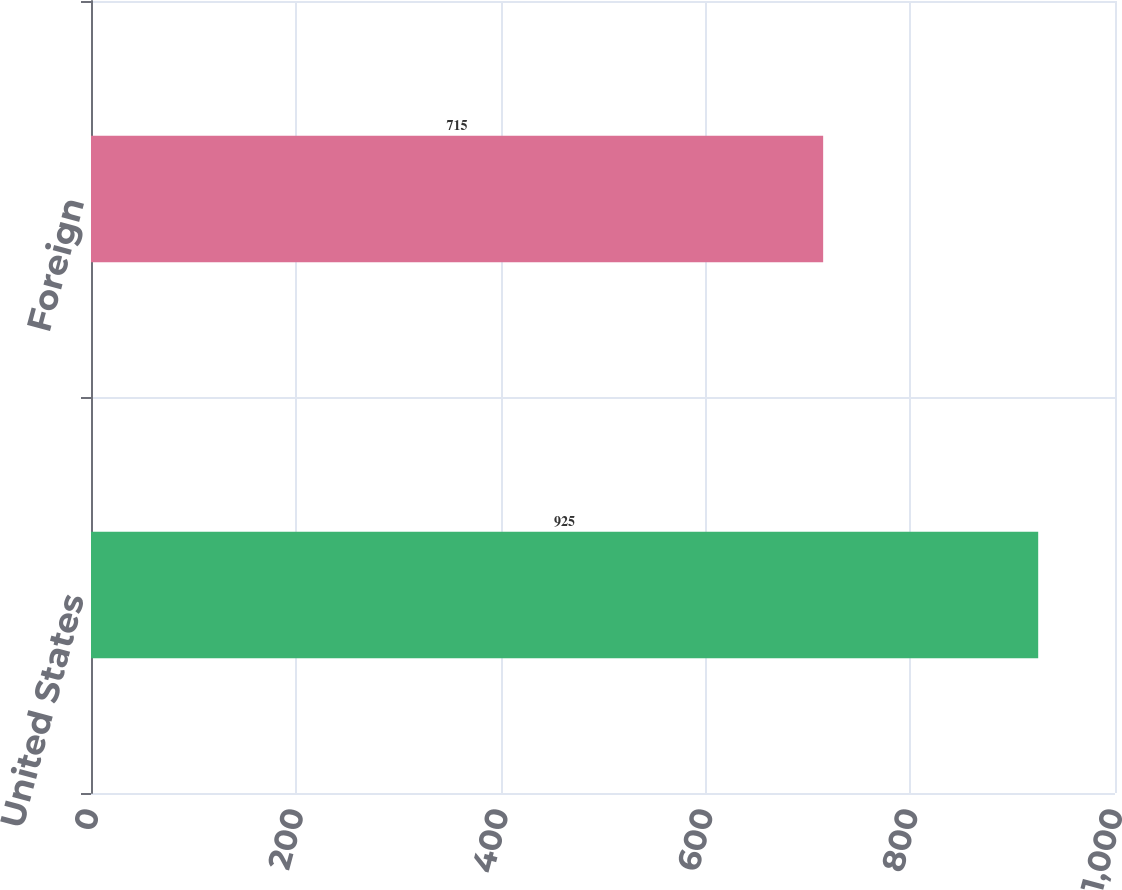<chart> <loc_0><loc_0><loc_500><loc_500><bar_chart><fcel>United States<fcel>Foreign<nl><fcel>925<fcel>715<nl></chart> 